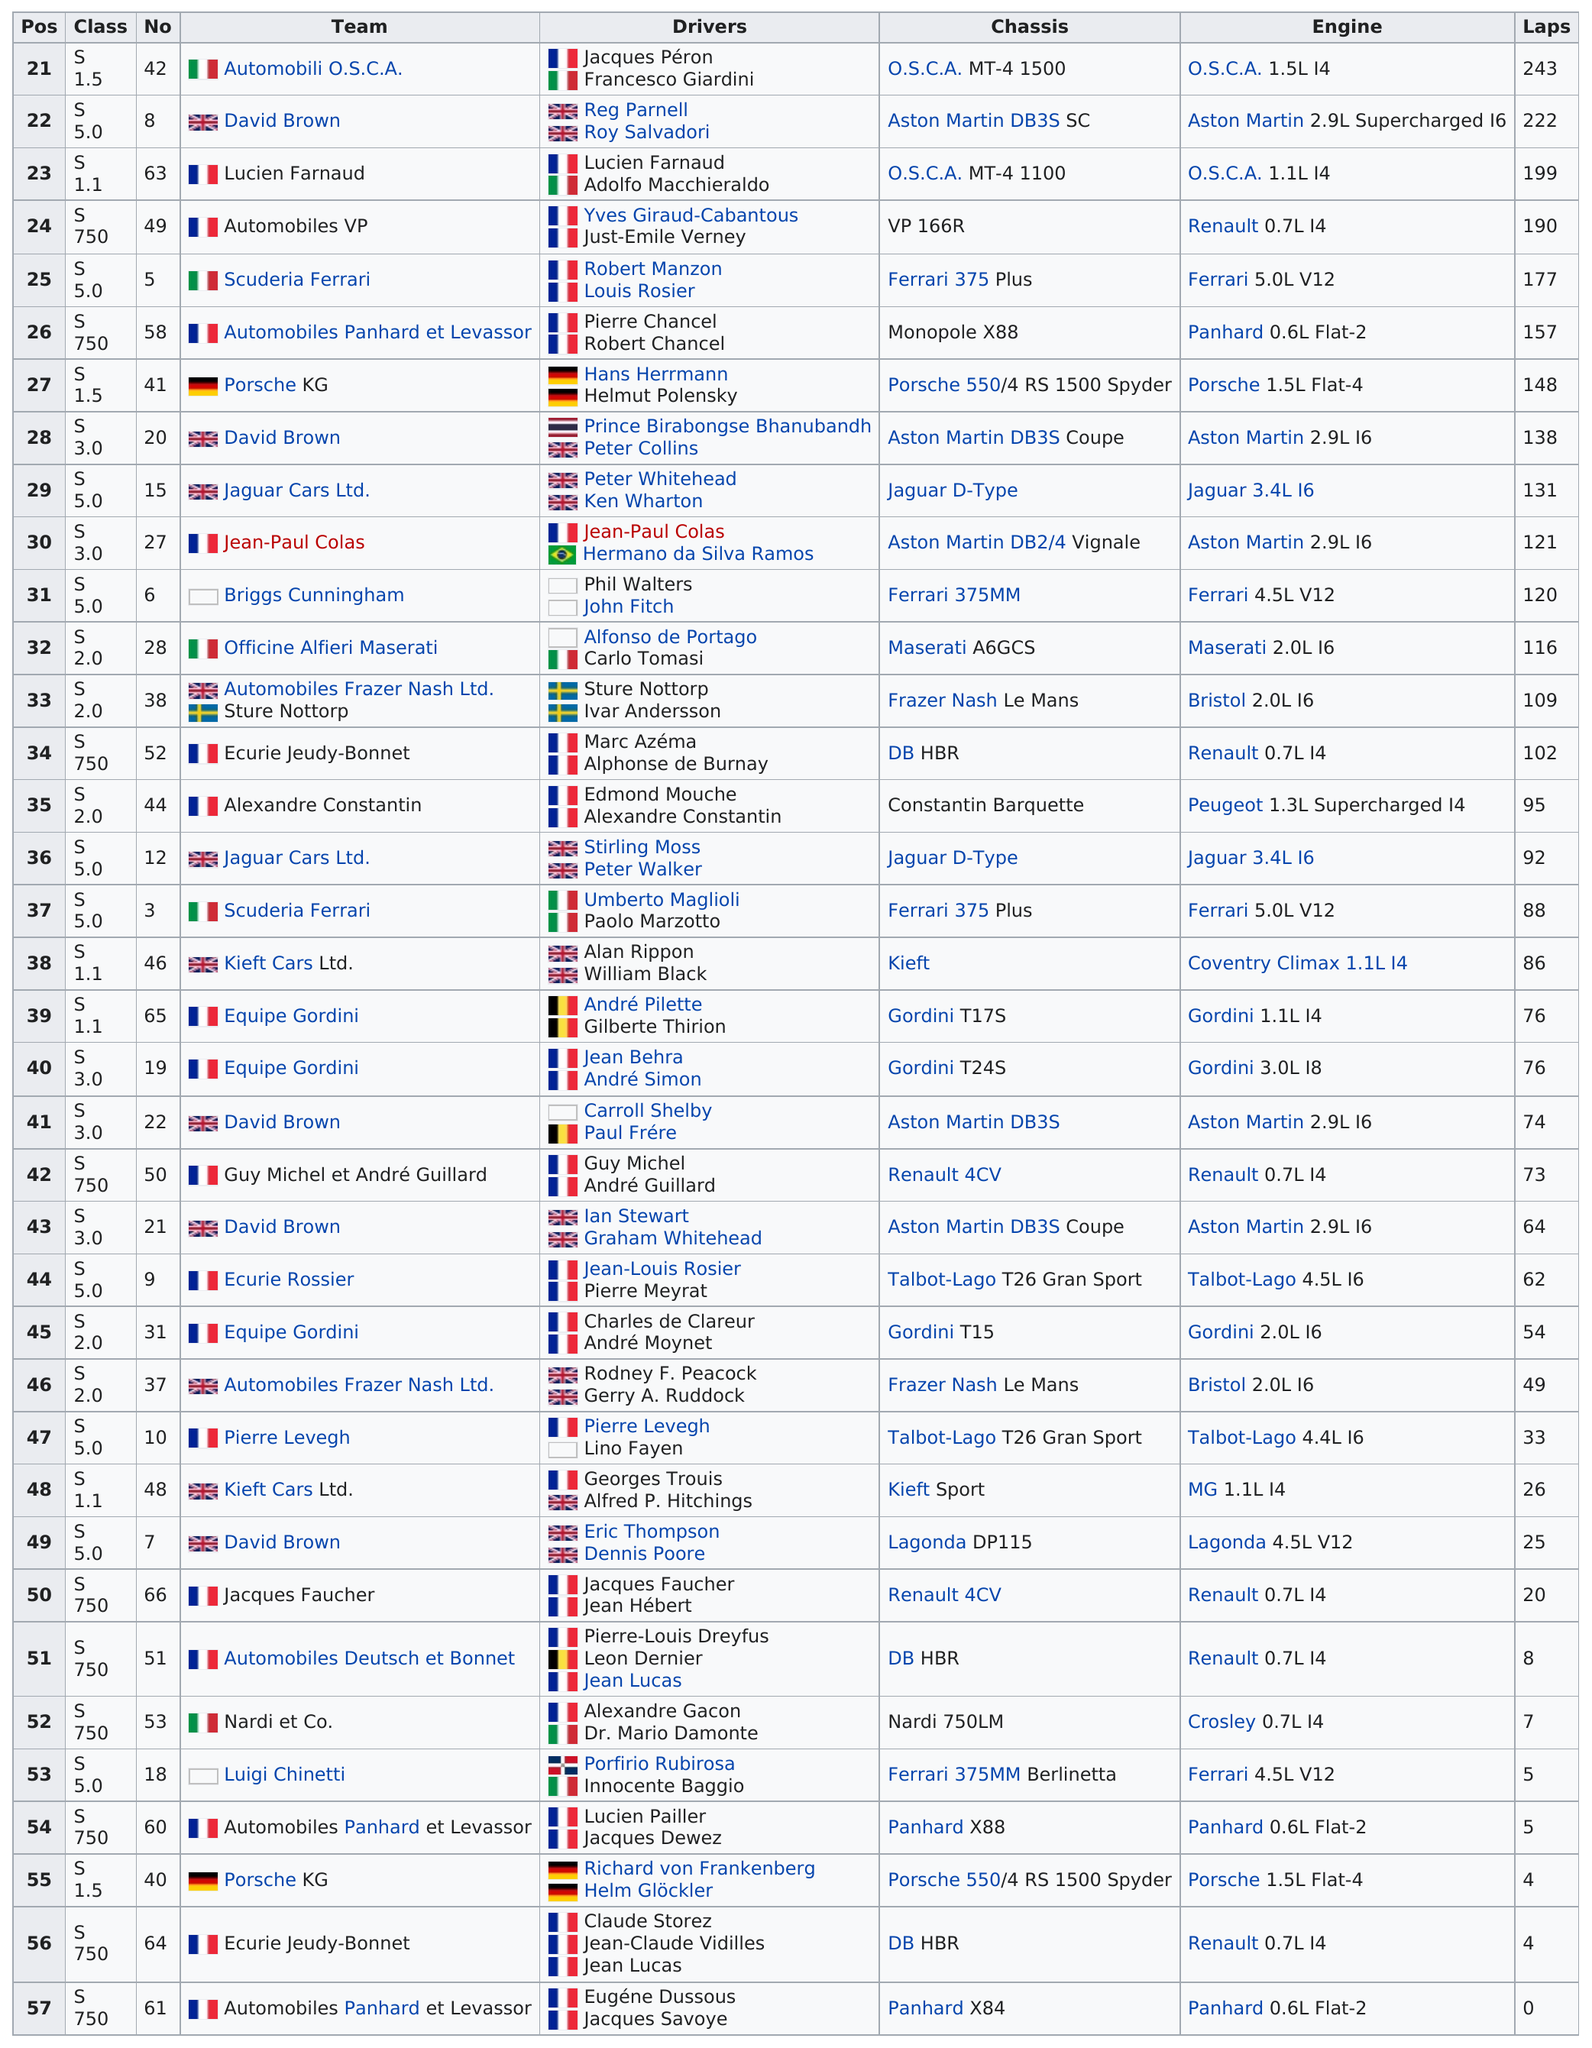Give some essential details in this illustration. Out of the 12 teams participating in the tournament, 11 of them are from Great Britain. Automobili O.S.C.A. and David Brown made the most laps during the race. Automobili O.S.C.A. team had the most number of laps in the race. The team of Automobiles Panhard et Levassor did not complete a single lap in the competition. Nardi et al., the team that only completed 7 laps, is the subject of the sentence. 